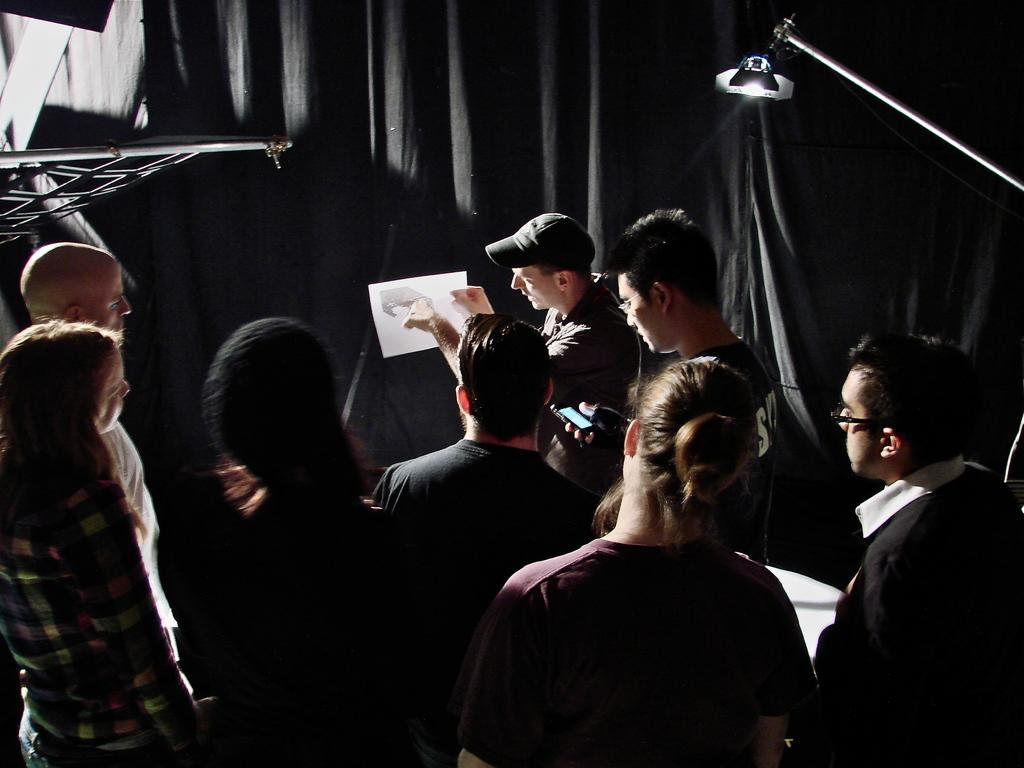What is happening in the image? There is a group of people standing in the image. Can you describe any objects in the image? Yes, there is a lamp in the top right corner of the image and a rod in the top left corner of the image. What can be seen in the background of the image? There is a black curtain in the background of the image. What type of skin condition is visible on the people in the image? There is no indication of any skin condition visible on the people in the image. 